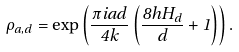Convert formula to latex. <formula><loc_0><loc_0><loc_500><loc_500>\rho _ { a , d } = \exp \left ( \frac { \pi i a d } { 4 k } \left ( \frac { 8 h H _ { d } } { d } + 1 \right ) \right ) .</formula> 